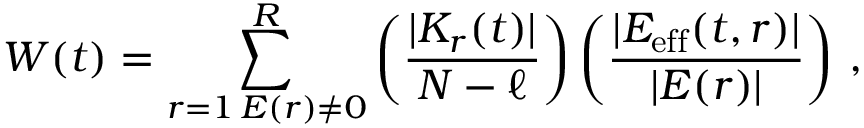Convert formula to latex. <formula><loc_0><loc_0><loc_500><loc_500>W ( t ) = \sum _ { \substack { r = 1 \, E ( r ) \neq 0 } } ^ { R } \left ( \frac { | K _ { r } ( t ) | } { N - \ell } \right ) \left ( \frac { | E _ { e f f } ( t , r ) | } { | E ( r ) | } \right ) \, ,</formula> 